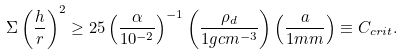<formula> <loc_0><loc_0><loc_500><loc_500>\Sigma \left ( \frac { h } { r } \right ) ^ { 2 } \geq 2 5 \left ( \frac { \alpha } { 1 0 ^ { - 2 } } \right ) ^ { - 1 } \left ( \frac { \rho _ { d } } { 1 g c m ^ { - 3 } } \right ) \left ( \frac { a } { 1 m m } \right ) \equiv C _ { c r i t } .</formula> 